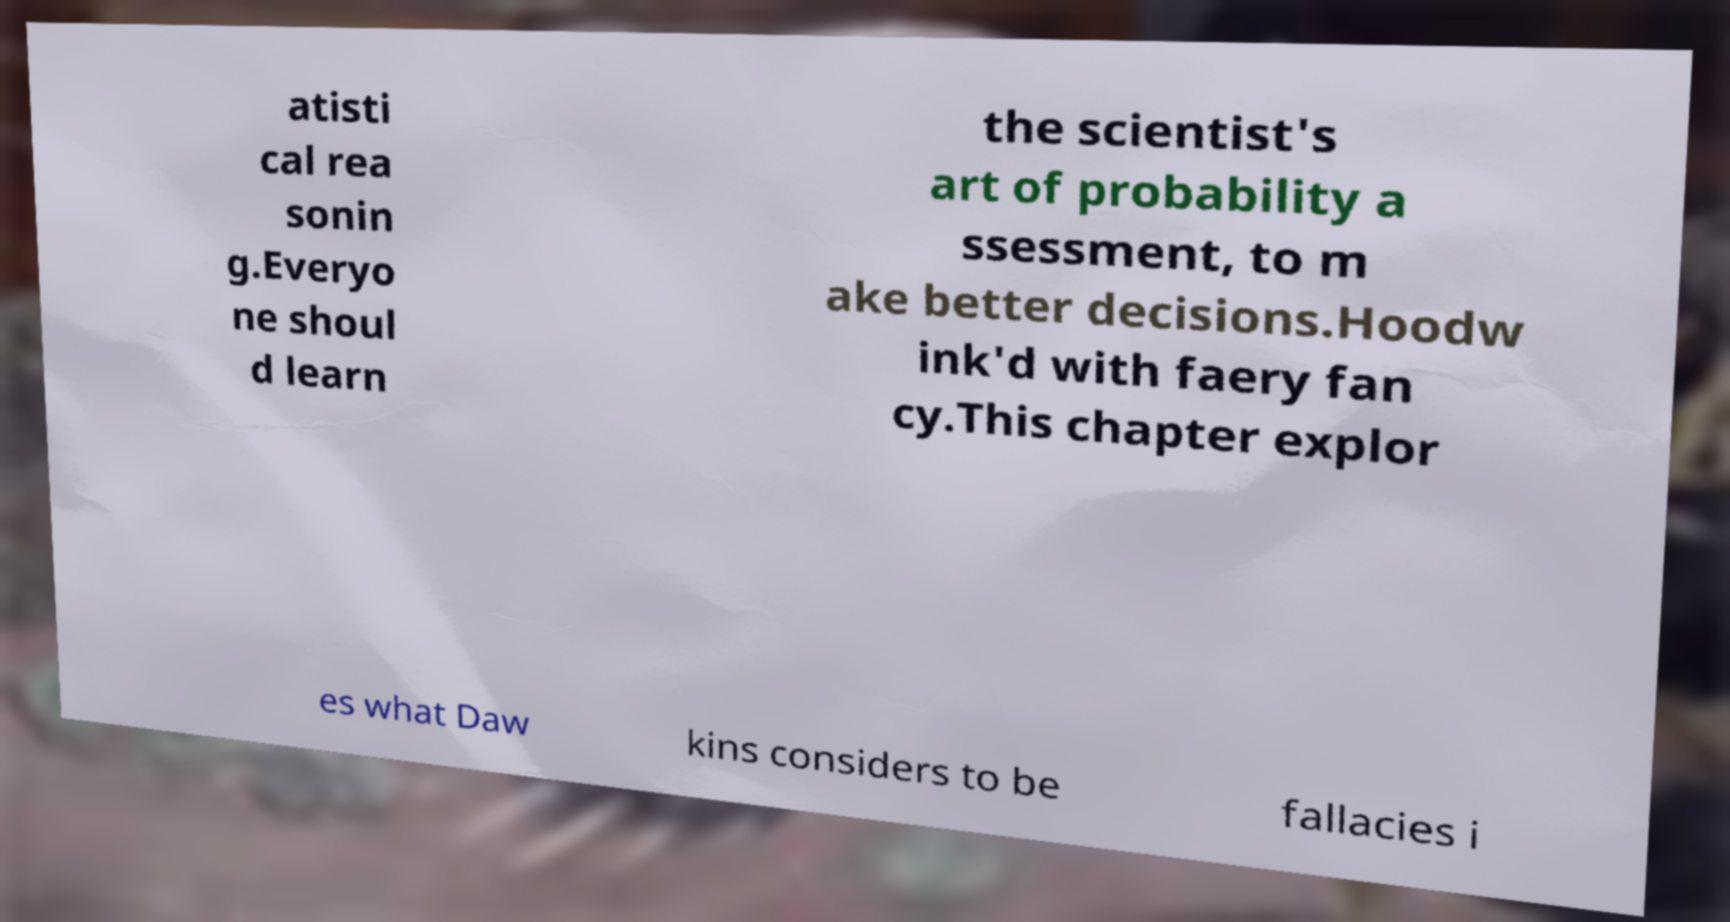Please identify and transcribe the text found in this image. atisti cal rea sonin g.Everyo ne shoul d learn the scientist's art of probability a ssessment, to m ake better decisions.Hoodw ink'd with faery fan cy.This chapter explor es what Daw kins considers to be fallacies i 